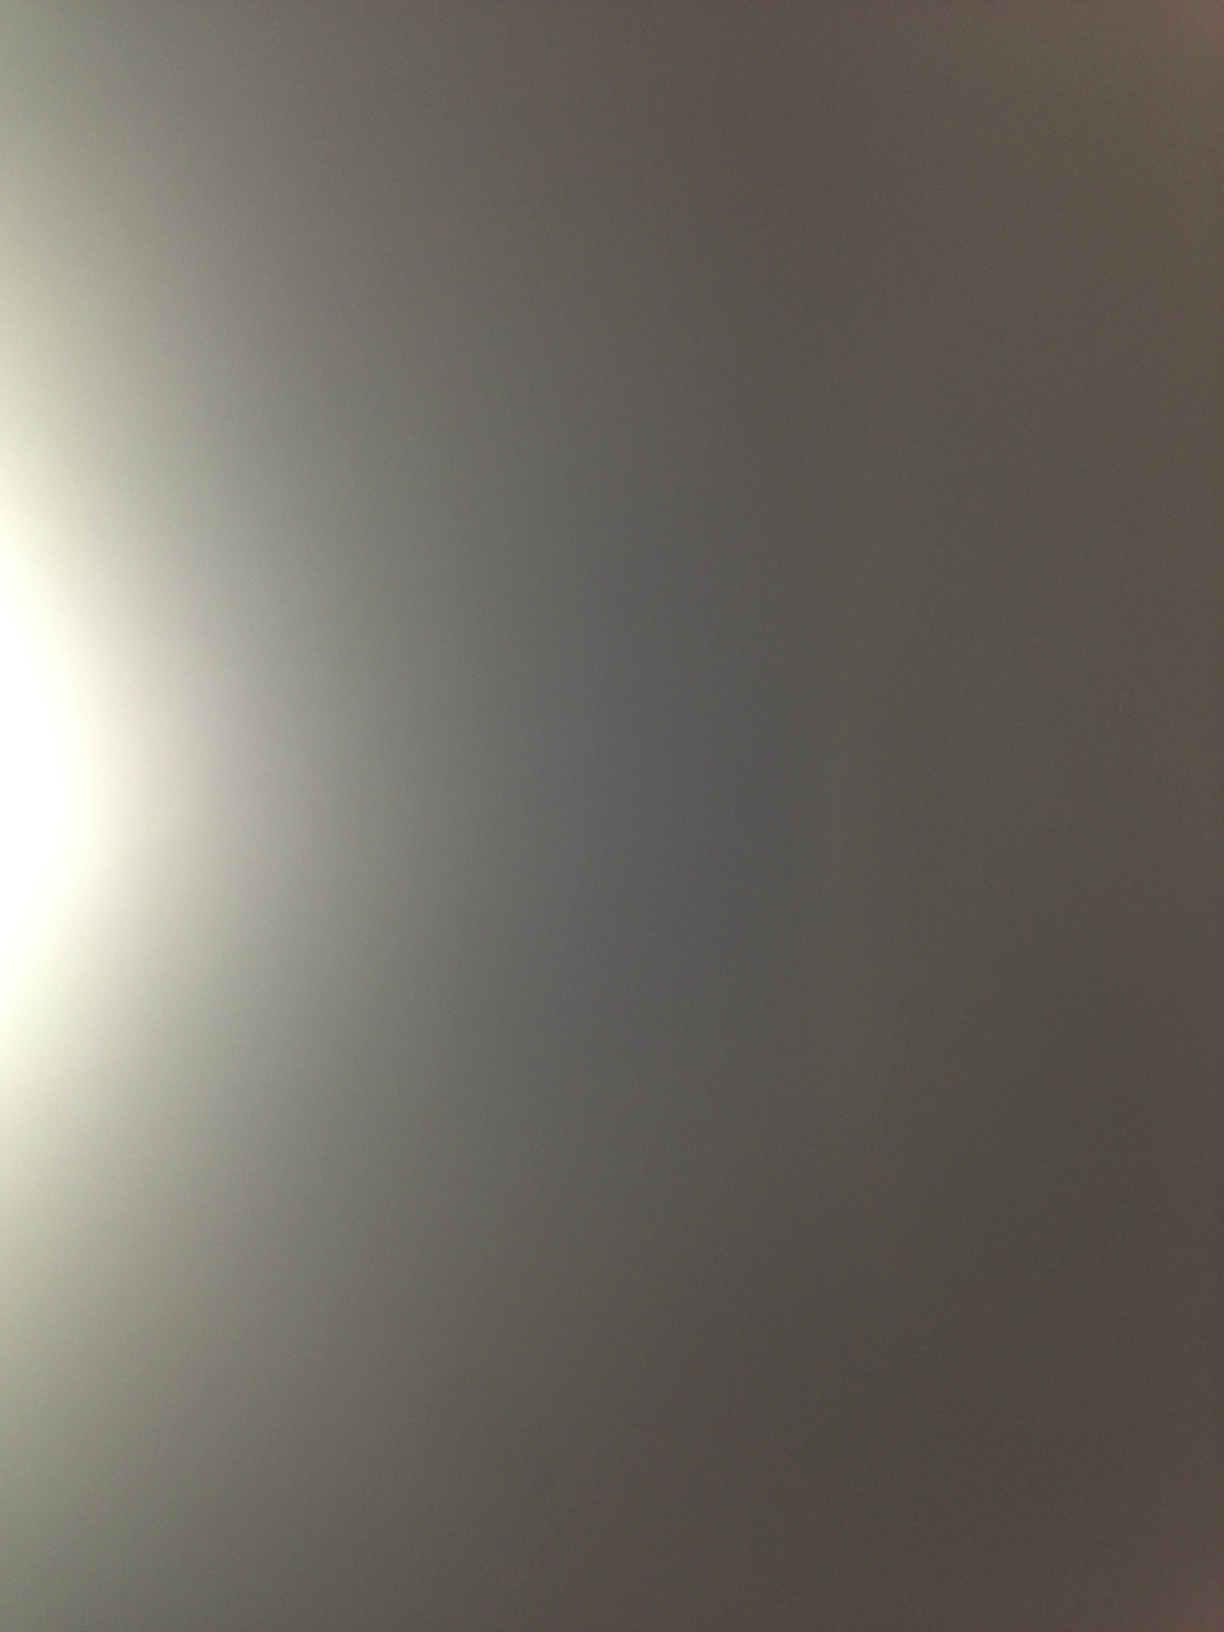What colors can you see in the image? The image seems to display a gradient of colors ranging from light gray to a darker shade, perhaps with a subtle hint of beige or brown near the edges. The exact colors can vary based on the display and perception. Do you think this image represents a specific time of day? This image could be interpreted as representing a range of times of day, depending on one's perspective. The gentle gradient could suggest early morning with soft light coming through mist or clouds, or possibly late evening as daylight fades. However, without more context, it is open to interpretation. Could this image be an abstract representation of an idea or emotion? Absolutely. Abstract images like this can evoke various emotions or ideas depending on the viewer. The gentle gradient could symbolize calmness, serenity, or transition. The lack of distinct shapes could suggest ambiguity or introspection. Abstract art allows for a broad range of interpretations and emotional responses. 